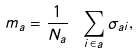<formula> <loc_0><loc_0><loc_500><loc_500>m _ { a } = \frac { 1 } { N _ { a } } \ \sum _ { i \in a } \sigma _ { a i } ,</formula> 